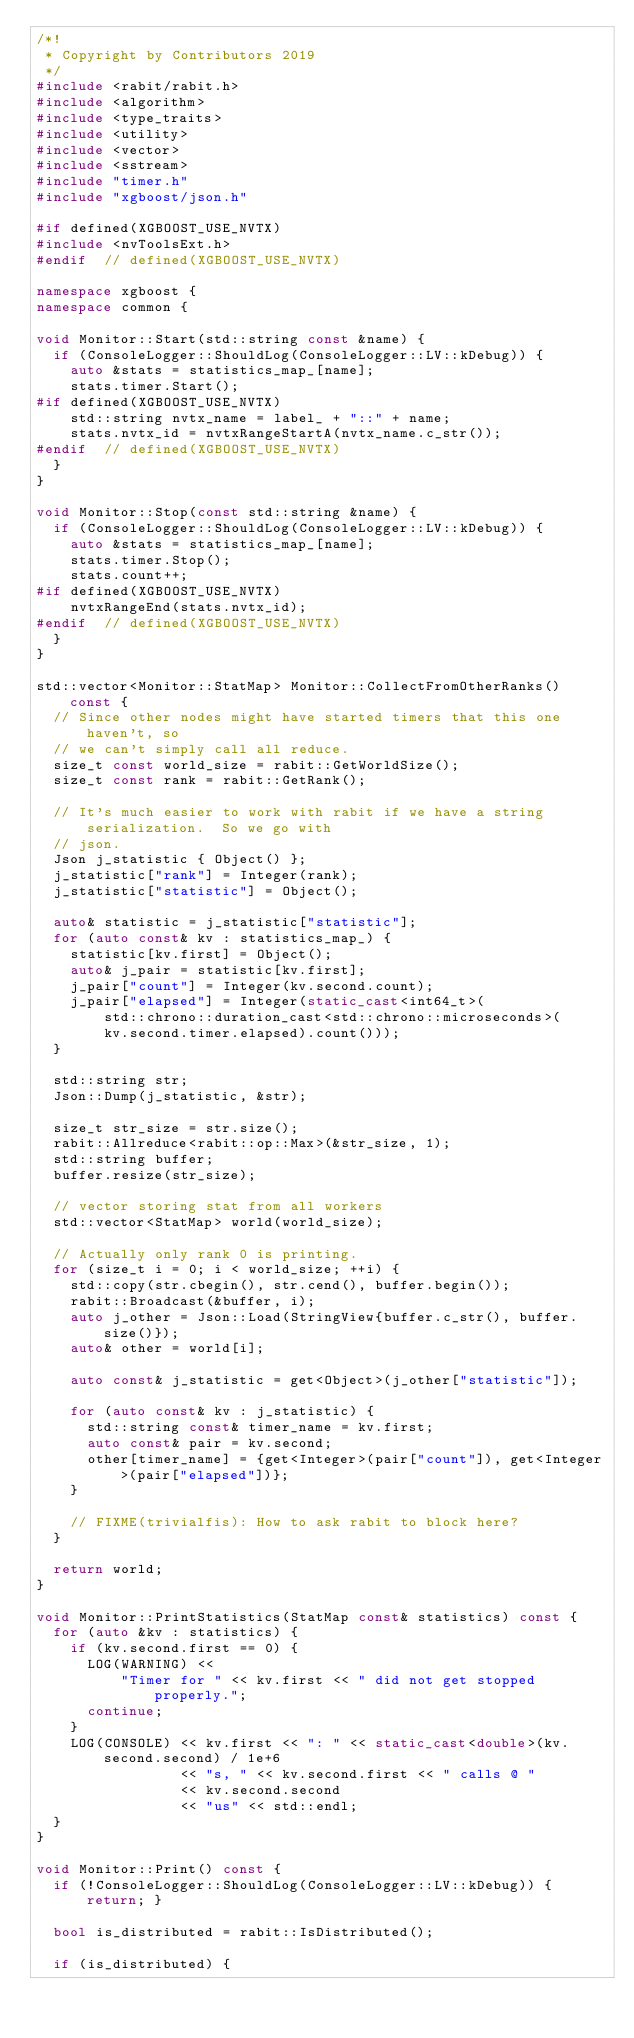Convert code to text. <code><loc_0><loc_0><loc_500><loc_500><_C++_>/*!
 * Copyright by Contributors 2019
 */
#include <rabit/rabit.h>
#include <algorithm>
#include <type_traits>
#include <utility>
#include <vector>
#include <sstream>
#include "timer.h"
#include "xgboost/json.h"

#if defined(XGBOOST_USE_NVTX)
#include <nvToolsExt.h>
#endif  // defined(XGBOOST_USE_NVTX)

namespace xgboost {
namespace common {

void Monitor::Start(std::string const &name) {
  if (ConsoleLogger::ShouldLog(ConsoleLogger::LV::kDebug)) {
    auto &stats = statistics_map_[name];
    stats.timer.Start();
#if defined(XGBOOST_USE_NVTX)
    std::string nvtx_name = label_ + "::" + name;
    stats.nvtx_id = nvtxRangeStartA(nvtx_name.c_str());
#endif  // defined(XGBOOST_USE_NVTX)
  }
}

void Monitor::Stop(const std::string &name) {
  if (ConsoleLogger::ShouldLog(ConsoleLogger::LV::kDebug)) {
    auto &stats = statistics_map_[name];
    stats.timer.Stop();
    stats.count++;
#if defined(XGBOOST_USE_NVTX)
    nvtxRangeEnd(stats.nvtx_id);
#endif  // defined(XGBOOST_USE_NVTX)
  }
}

std::vector<Monitor::StatMap> Monitor::CollectFromOtherRanks() const {
  // Since other nodes might have started timers that this one haven't, so
  // we can't simply call all reduce.
  size_t const world_size = rabit::GetWorldSize();
  size_t const rank = rabit::GetRank();

  // It's much easier to work with rabit if we have a string serialization.  So we go with
  // json.
  Json j_statistic { Object() };
  j_statistic["rank"] = Integer(rank);
  j_statistic["statistic"] = Object();

  auto& statistic = j_statistic["statistic"];
  for (auto const& kv : statistics_map_) {
    statistic[kv.first] = Object();
    auto& j_pair = statistic[kv.first];
    j_pair["count"] = Integer(kv.second.count);
    j_pair["elapsed"] = Integer(static_cast<int64_t>(
        std::chrono::duration_cast<std::chrono::microseconds>(
        kv.second.timer.elapsed).count()));
  }

  std::string str;
  Json::Dump(j_statistic, &str);

  size_t str_size = str.size();
  rabit::Allreduce<rabit::op::Max>(&str_size, 1);
  std::string buffer;
  buffer.resize(str_size);

  // vector storing stat from all workers
  std::vector<StatMap> world(world_size);

  // Actually only rank 0 is printing.
  for (size_t i = 0; i < world_size; ++i) {
    std::copy(str.cbegin(), str.cend(), buffer.begin());
    rabit::Broadcast(&buffer, i);
    auto j_other = Json::Load(StringView{buffer.c_str(), buffer.size()});
    auto& other = world[i];

    auto const& j_statistic = get<Object>(j_other["statistic"]);

    for (auto const& kv : j_statistic) {
      std::string const& timer_name = kv.first;
      auto const& pair = kv.second;
      other[timer_name] = {get<Integer>(pair["count"]), get<Integer>(pair["elapsed"])};
    }

    // FIXME(trivialfis): How to ask rabit to block here?
  }

  return world;
}

void Monitor::PrintStatistics(StatMap const& statistics) const {
  for (auto &kv : statistics) {
    if (kv.second.first == 0) {
      LOG(WARNING) <<
          "Timer for " << kv.first << " did not get stopped properly.";
      continue;
    }
    LOG(CONSOLE) << kv.first << ": " << static_cast<double>(kv.second.second) / 1e+6
                 << "s, " << kv.second.first << " calls @ "
                 << kv.second.second
                 << "us" << std::endl;
  }
}

void Monitor::Print() const {
  if (!ConsoleLogger::ShouldLog(ConsoleLogger::LV::kDebug)) { return; }

  bool is_distributed = rabit::IsDistributed();

  if (is_distributed) {</code> 